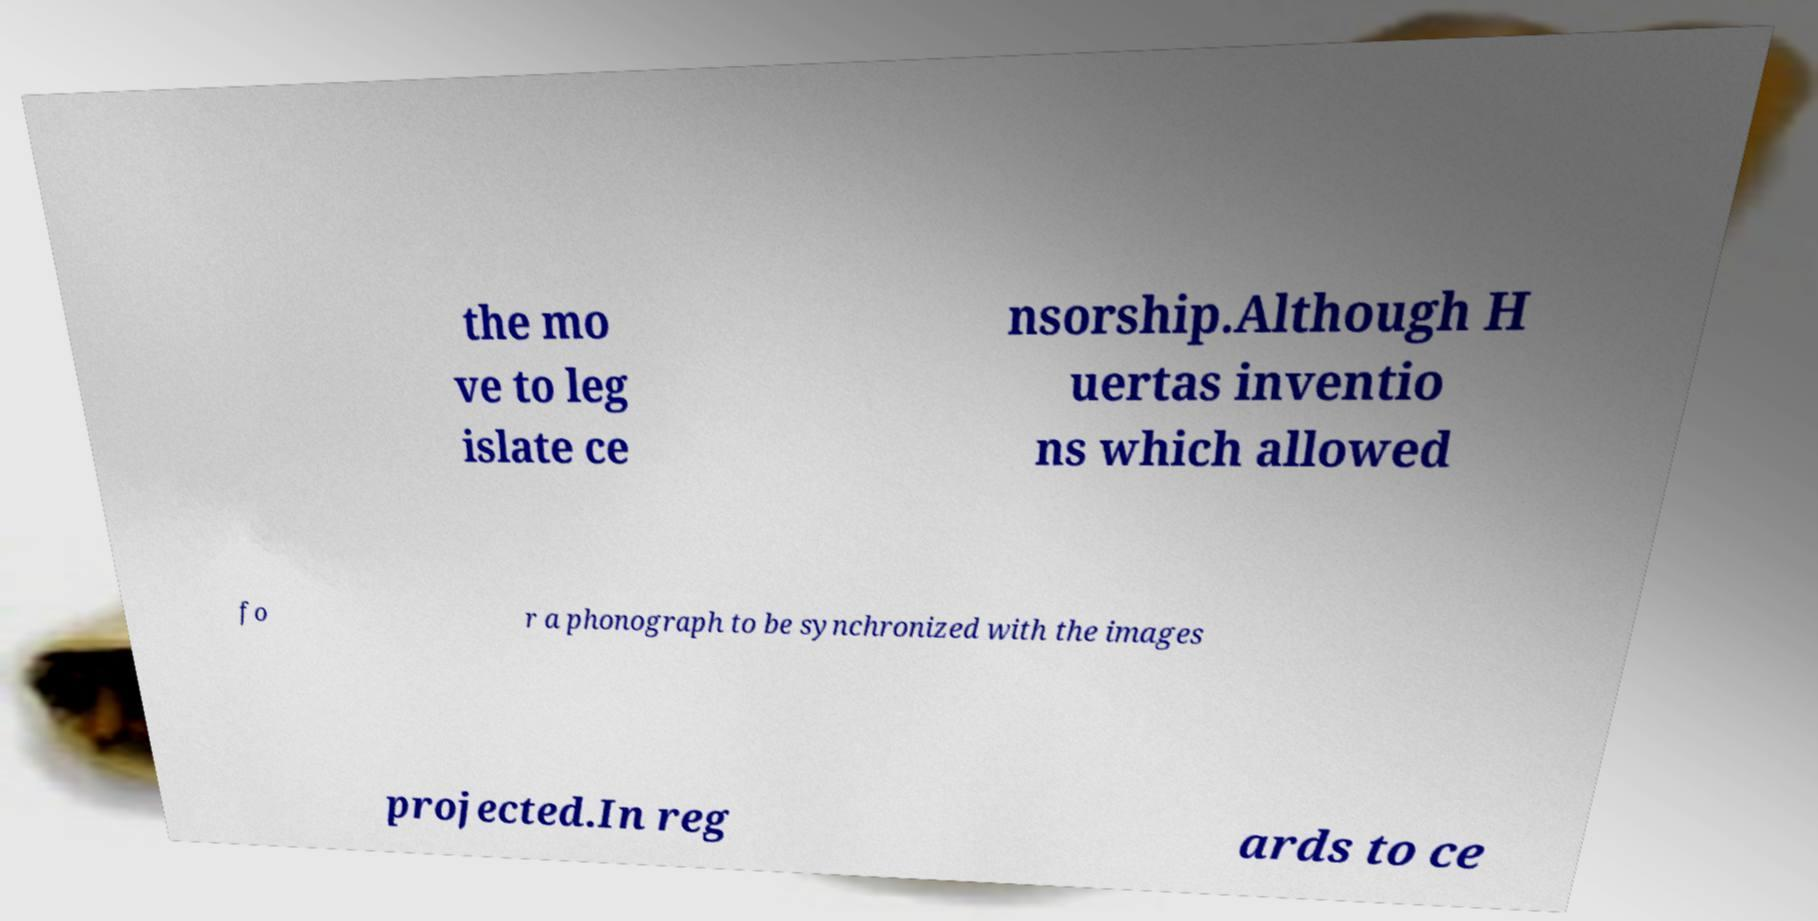I need the written content from this picture converted into text. Can you do that? the mo ve to leg islate ce nsorship.Although H uertas inventio ns which allowed fo r a phonograph to be synchronized with the images projected.In reg ards to ce 